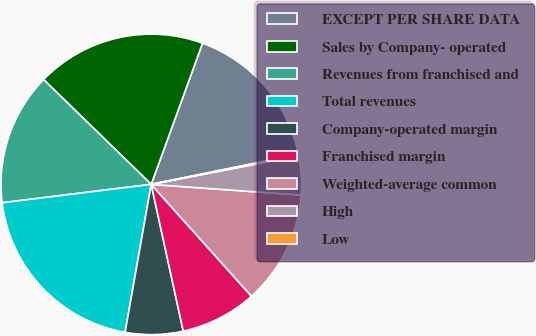<chart> <loc_0><loc_0><loc_500><loc_500><pie_chart><fcel>EXCEPT PER SHARE DATA<fcel>Sales by Company- operated<fcel>Revenues from franchised and<fcel>Total revenues<fcel>Company-operated margin<fcel>Franchised margin<fcel>Weighted-average common<fcel>High<fcel>Low<nl><fcel>16.25%<fcel>18.26%<fcel>14.24%<fcel>20.27%<fcel>6.2%<fcel>8.21%<fcel>12.23%<fcel>4.18%<fcel>0.16%<nl></chart> 